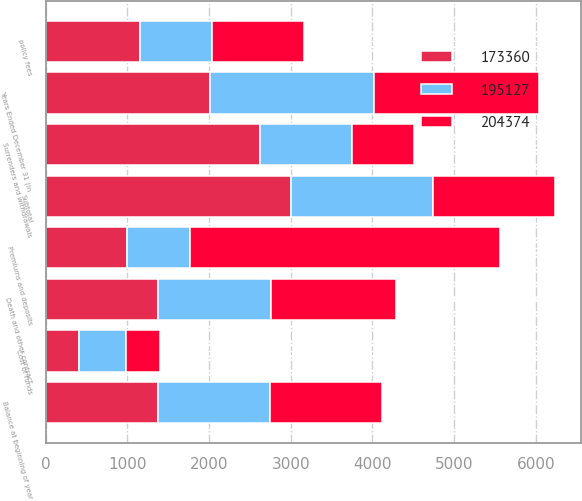Convert chart. <chart><loc_0><loc_0><loc_500><loc_500><stacked_bar_chart><ecel><fcel>Years Ended December 31 (in<fcel>Balance at beginning of year<fcel>Premiums and deposits<fcel>Surrenders and withdrawals<fcel>Death and other contract<fcel>Subtotal<fcel>policy fees<fcel>Cost of funds<nl><fcel>204374<fcel>2014<fcel>1371<fcel>3797<fcel>766<fcel>1530<fcel>1501<fcel>1130<fcel>410<nl><fcel>173360<fcel>2013<fcel>1371<fcel>991<fcel>2620<fcel>1371<fcel>3000<fcel>1156<fcel>413<nl><fcel>195127<fcel>2012<fcel>1371<fcel>774<fcel>1128<fcel>1384<fcel>1738<fcel>876<fcel>571<nl></chart> 